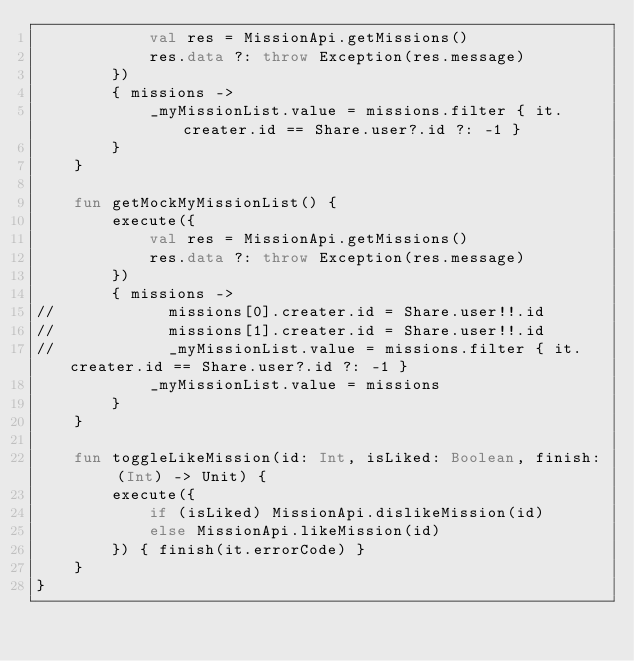Convert code to text. <code><loc_0><loc_0><loc_500><loc_500><_Kotlin_>            val res = MissionApi.getMissions()
            res.data ?: throw Exception(res.message)
        })
        { missions ->
            _myMissionList.value = missions.filter { it.creater.id == Share.user?.id ?: -1 }
        }
    }

    fun getMockMyMissionList() {
        execute({
            val res = MissionApi.getMissions()
            res.data ?: throw Exception(res.message)
        })
        { missions ->
//            missions[0].creater.id = Share.user!!.id
//            missions[1].creater.id = Share.user!!.id
//            _myMissionList.value = missions.filter { it.creater.id == Share.user?.id ?: -1 }
            _myMissionList.value = missions
        }
    }

    fun toggleLikeMission(id: Int, isLiked: Boolean, finish: (Int) -> Unit) {
        execute({
            if (isLiked) MissionApi.dislikeMission(id)
            else MissionApi.likeMission(id)
        }) { finish(it.errorCode) }
    }
}</code> 